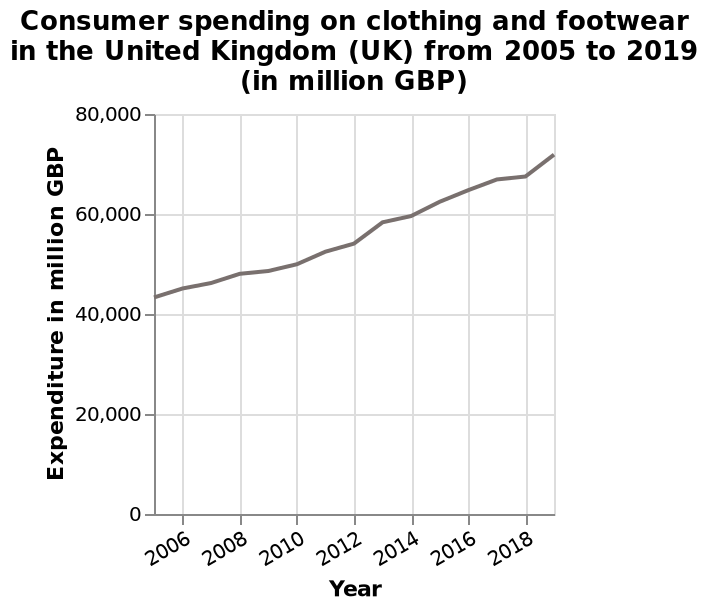<image>
What is the name of the line plot?  The line plot is named "Consumer spending on clothing and footwear in the United Kingdom (UK) from 2005 to 2019. Describe the following image in detail This is a line plot named Consumer spending on clothing and footwear in the United Kingdom (UK) from 2005 to 2019 (in million GBP). Expenditure in million GBP is plotted on the y-axis. There is a linear scale from 2006 to 2018 along the x-axis, marked Year. 